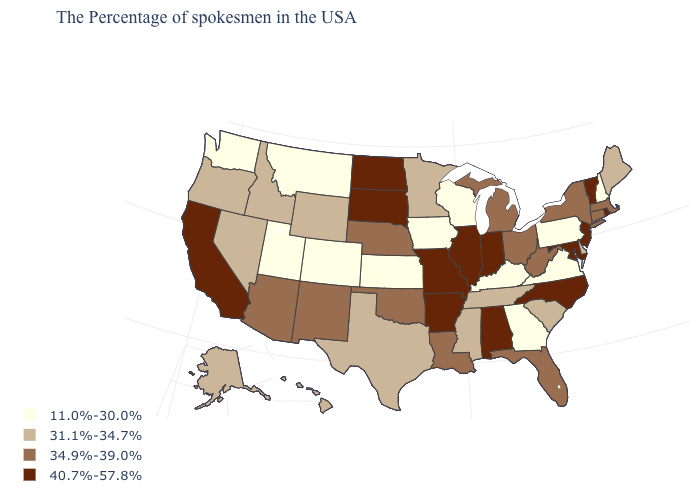What is the highest value in states that border New Jersey?
Concise answer only. 34.9%-39.0%. What is the value of North Carolina?
Be succinct. 40.7%-57.8%. Which states hav the highest value in the South?
Keep it brief. Maryland, North Carolina, Alabama, Arkansas. Which states have the lowest value in the USA?
Short answer required. New Hampshire, Pennsylvania, Virginia, Georgia, Kentucky, Wisconsin, Iowa, Kansas, Colorado, Utah, Montana, Washington. What is the highest value in the MidWest ?
Answer briefly. 40.7%-57.8%. What is the lowest value in the USA?
Give a very brief answer. 11.0%-30.0%. Does the map have missing data?
Answer briefly. No. Does New York have the highest value in the USA?
Be succinct. No. Among the states that border Georgia , which have the lowest value?
Write a very short answer. South Carolina, Tennessee. Does Vermont have the lowest value in the USA?
Give a very brief answer. No. Among the states that border Alabama , which have the lowest value?
Give a very brief answer. Georgia. Among the states that border Wyoming , which have the lowest value?
Keep it brief. Colorado, Utah, Montana. Which states hav the highest value in the South?
Write a very short answer. Maryland, North Carolina, Alabama, Arkansas. Does West Virginia have the same value as Arkansas?
Write a very short answer. No. 